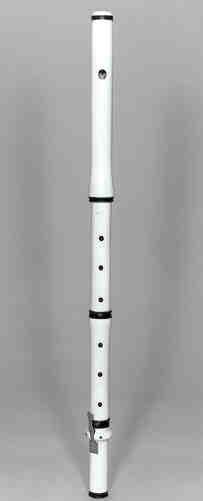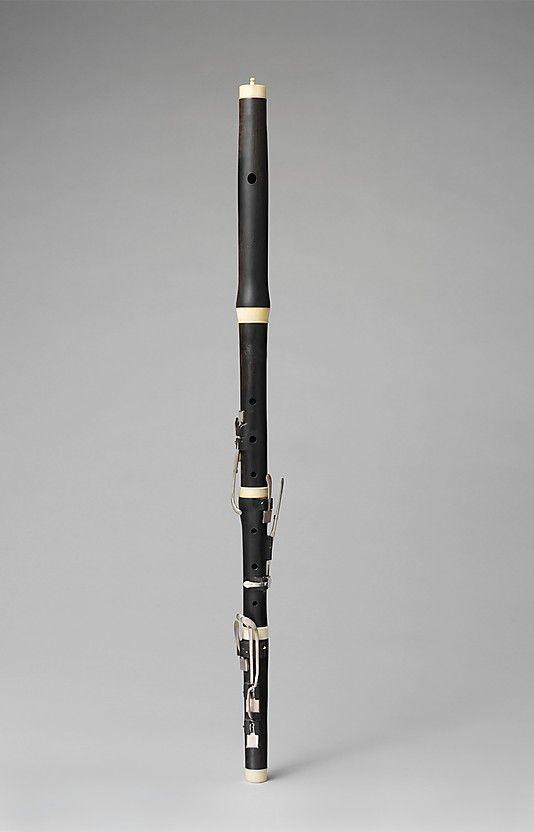The first image is the image on the left, the second image is the image on the right. Considering the images on both sides, is "The instrument on the left has several rings going around its body." valid? Answer yes or no. Yes. 